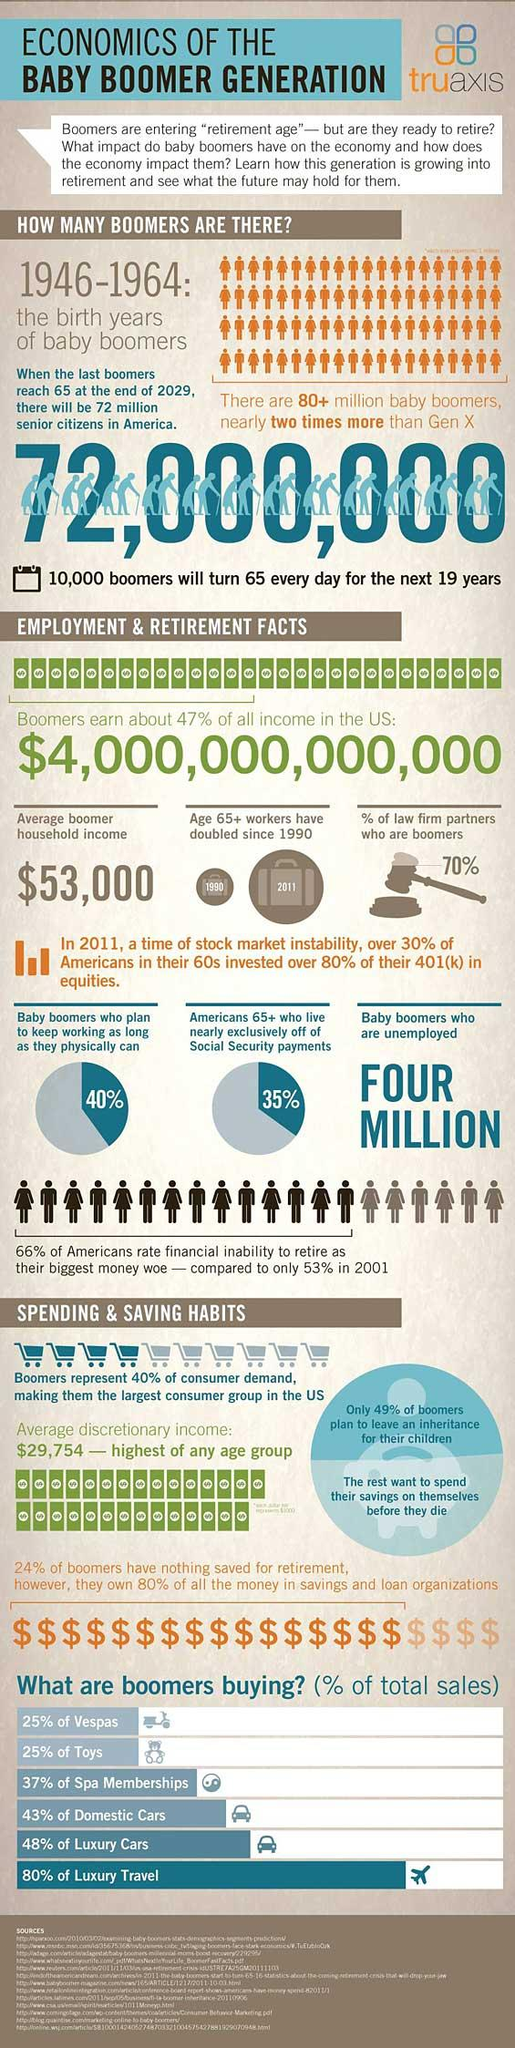Indicate a few pertinent items in this graphic. In America, 30% of law firm partners are not baby boomers. The population of baby boomers in America is approximately 72 million. The average discretionary income of baby boomers in America is $29,754. According to the survey, 40% of baby boomers plan to continue working as long as they are physically able. A recent survey conducted in America has revealed that 51% of baby boomers plan to spend their savings on themselves. 